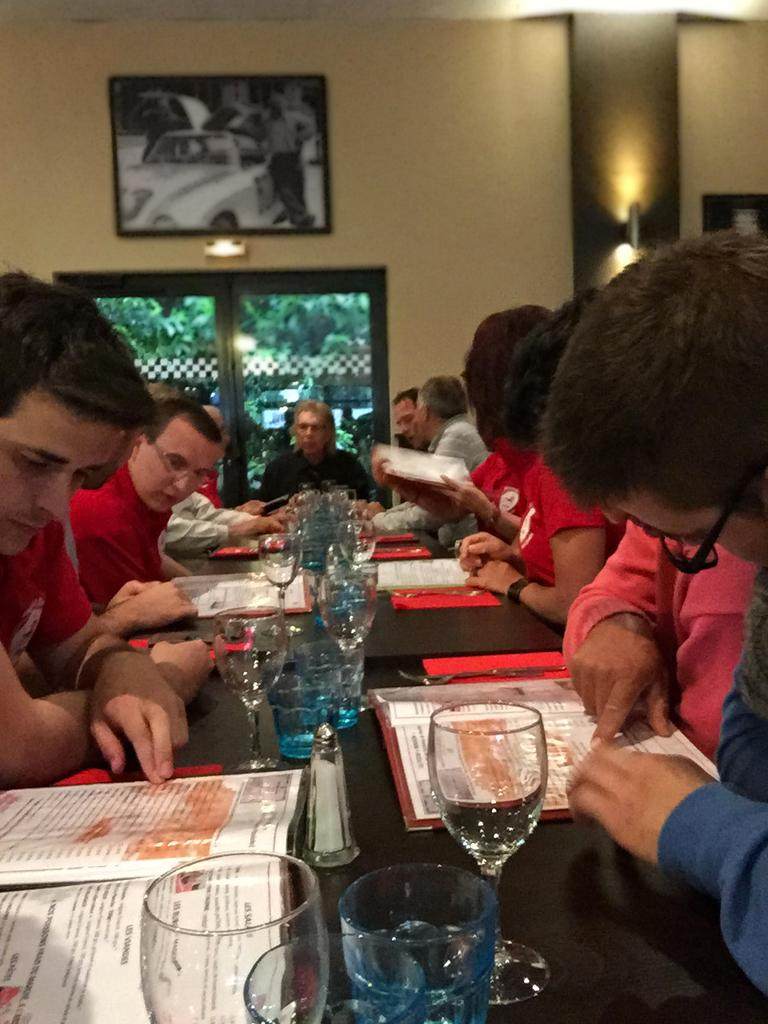What are the people in the image doing? The people in the image are sitting on chairs. What objects can be seen on the table in the image? There are wine glasses on the table in the image. Where is the seed planted in the image? There is no seed or planting activity present in the image. 